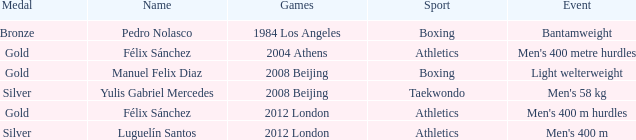What Medal had a Name of manuel felix diaz? Gold. 